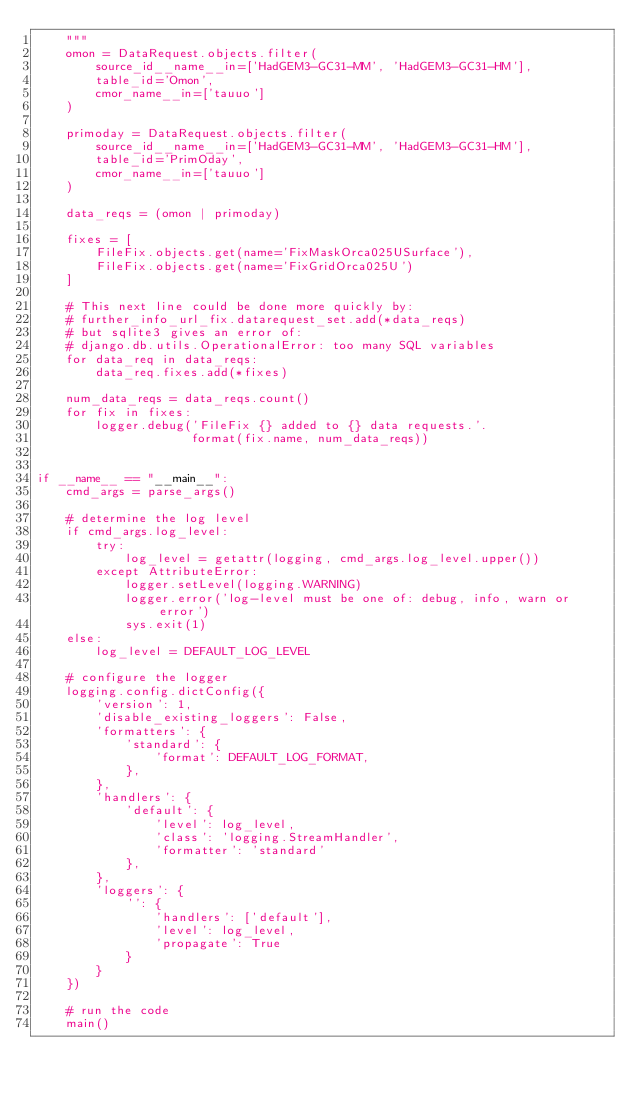Convert code to text. <code><loc_0><loc_0><loc_500><loc_500><_Python_>    """
    omon = DataRequest.objects.filter(
        source_id__name__in=['HadGEM3-GC31-MM', 'HadGEM3-GC31-HM'],
        table_id='Omon',
        cmor_name__in=['tauuo']
    )

    primoday = DataRequest.objects.filter(
        source_id__name__in=['HadGEM3-GC31-MM', 'HadGEM3-GC31-HM'],
        table_id='PrimOday',
        cmor_name__in=['tauuo']
    )

    data_reqs = (omon | primoday)

    fixes = [
        FileFix.objects.get(name='FixMaskOrca025USurface'),
        FileFix.objects.get(name='FixGridOrca025U')
    ]

    # This next line could be done more quickly by:
    # further_info_url_fix.datarequest_set.add(*data_reqs)
    # but sqlite3 gives an error of:
    # django.db.utils.OperationalError: too many SQL variables
    for data_req in data_reqs:
        data_req.fixes.add(*fixes)

    num_data_reqs = data_reqs.count()
    for fix in fixes:
        logger.debug('FileFix {} added to {} data requests.'.
                     format(fix.name, num_data_reqs))


if __name__ == "__main__":
    cmd_args = parse_args()

    # determine the log level
    if cmd_args.log_level:
        try:
            log_level = getattr(logging, cmd_args.log_level.upper())
        except AttributeError:
            logger.setLevel(logging.WARNING)
            logger.error('log-level must be one of: debug, info, warn or error')
            sys.exit(1)
    else:
        log_level = DEFAULT_LOG_LEVEL

    # configure the logger
    logging.config.dictConfig({
        'version': 1,
        'disable_existing_loggers': False,
        'formatters': {
            'standard': {
                'format': DEFAULT_LOG_FORMAT,
            },
        },
        'handlers': {
            'default': {
                'level': log_level,
                'class': 'logging.StreamHandler',
                'formatter': 'standard'
            },
        },
        'loggers': {
            '': {
                'handlers': ['default'],
                'level': log_level,
                'propagate': True
            }
        }
    })

    # run the code
    main()
</code> 